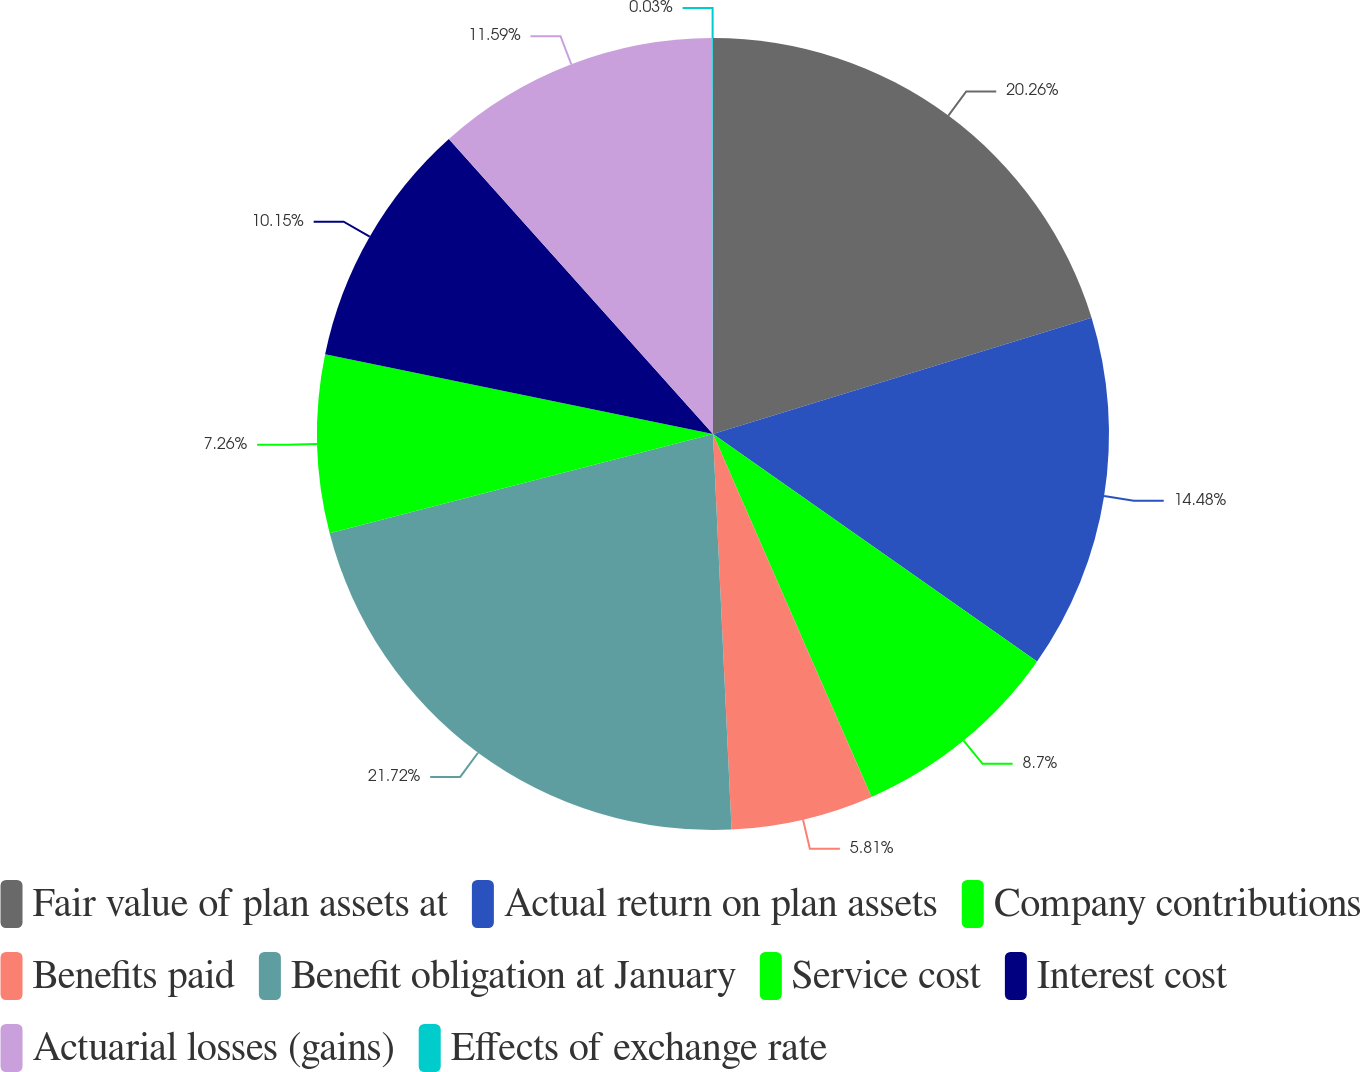Convert chart. <chart><loc_0><loc_0><loc_500><loc_500><pie_chart><fcel>Fair value of plan assets at<fcel>Actual return on plan assets<fcel>Company contributions<fcel>Benefits paid<fcel>Benefit obligation at January<fcel>Service cost<fcel>Interest cost<fcel>Actuarial losses (gains)<fcel>Effects of exchange rate<nl><fcel>20.26%<fcel>14.48%<fcel>8.7%<fcel>5.81%<fcel>21.71%<fcel>7.26%<fcel>10.15%<fcel>11.59%<fcel>0.03%<nl></chart> 